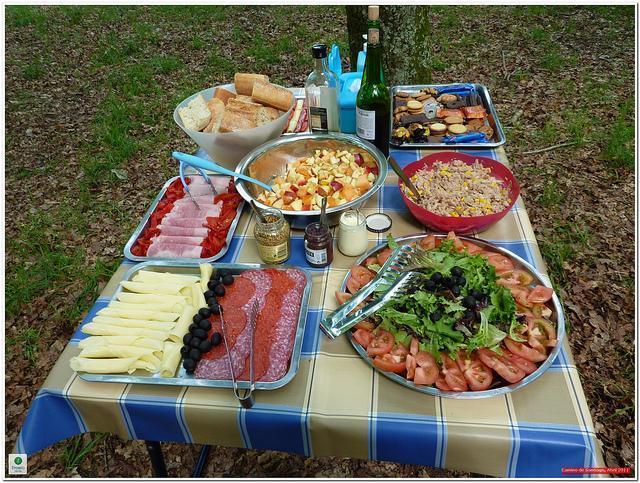How many bottles are there?
Give a very brief answer. 2. How many bowls are in the photo?
Give a very brief answer. 3. 